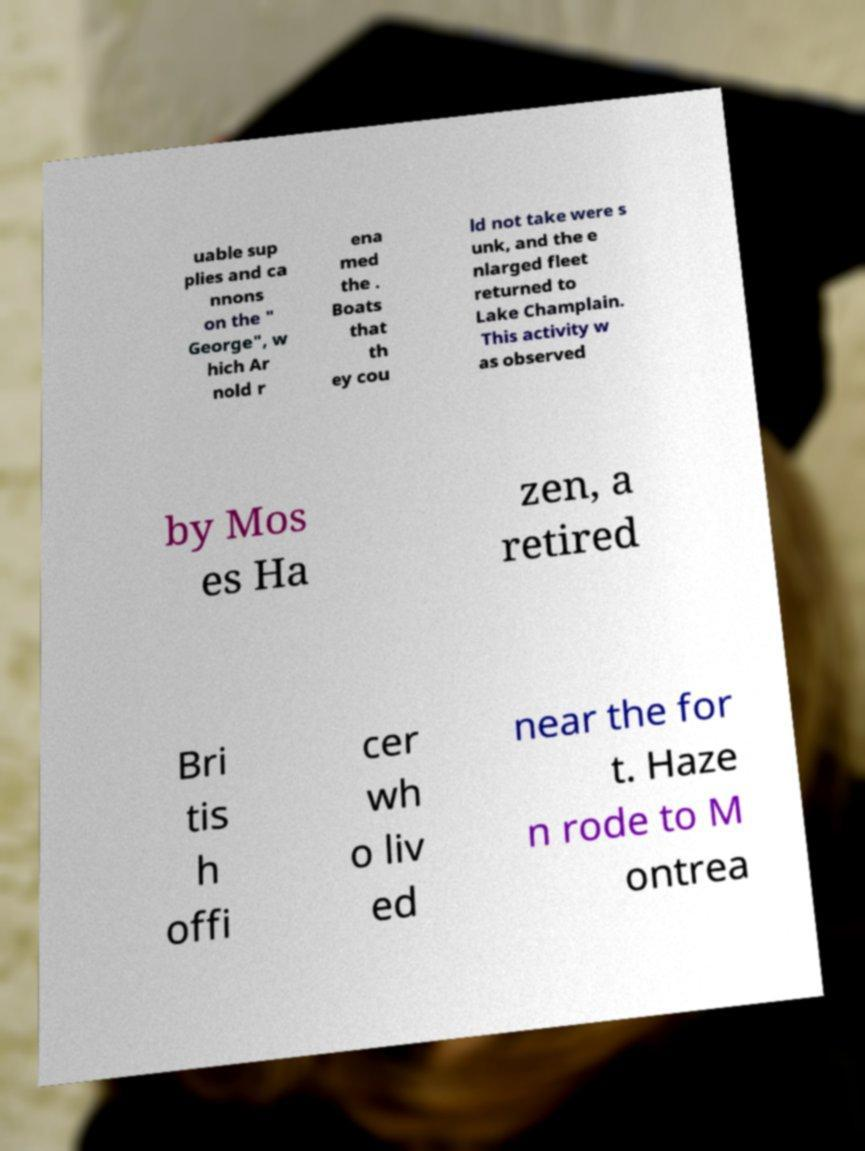I need the written content from this picture converted into text. Can you do that? uable sup plies and ca nnons on the " George", w hich Ar nold r ena med the . Boats that th ey cou ld not take were s unk, and the e nlarged fleet returned to Lake Champlain. This activity w as observed by Mos es Ha zen, a retired Bri tis h offi cer wh o liv ed near the for t. Haze n rode to M ontrea 